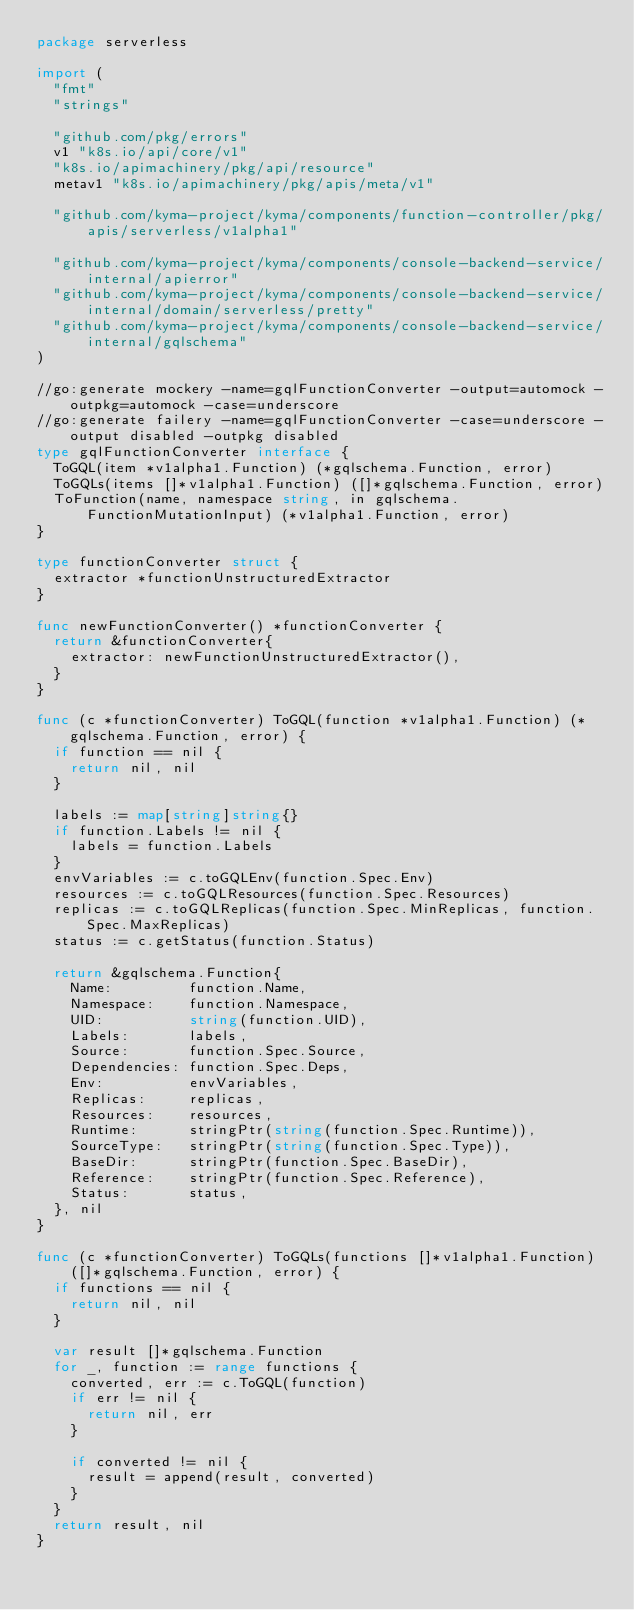Convert code to text. <code><loc_0><loc_0><loc_500><loc_500><_Go_>package serverless

import (
	"fmt"
	"strings"

	"github.com/pkg/errors"
	v1 "k8s.io/api/core/v1"
	"k8s.io/apimachinery/pkg/api/resource"
	metav1 "k8s.io/apimachinery/pkg/apis/meta/v1"

	"github.com/kyma-project/kyma/components/function-controller/pkg/apis/serverless/v1alpha1"

	"github.com/kyma-project/kyma/components/console-backend-service/internal/apierror"
	"github.com/kyma-project/kyma/components/console-backend-service/internal/domain/serverless/pretty"
	"github.com/kyma-project/kyma/components/console-backend-service/internal/gqlschema"
)

//go:generate mockery -name=gqlFunctionConverter -output=automock -outpkg=automock -case=underscore
//go:generate failery -name=gqlFunctionConverter -case=underscore -output disabled -outpkg disabled
type gqlFunctionConverter interface {
	ToGQL(item *v1alpha1.Function) (*gqlschema.Function, error)
	ToGQLs(items []*v1alpha1.Function) ([]*gqlschema.Function, error)
	ToFunction(name, namespace string, in gqlschema.FunctionMutationInput) (*v1alpha1.Function, error)
}

type functionConverter struct {
	extractor *functionUnstructuredExtractor
}

func newFunctionConverter() *functionConverter {
	return &functionConverter{
		extractor: newFunctionUnstructuredExtractor(),
	}
}

func (c *functionConverter) ToGQL(function *v1alpha1.Function) (*gqlschema.Function, error) {
	if function == nil {
		return nil, nil
	}

	labels := map[string]string{}
	if function.Labels != nil {
		labels = function.Labels
	}
	envVariables := c.toGQLEnv(function.Spec.Env)
	resources := c.toGQLResources(function.Spec.Resources)
	replicas := c.toGQLReplicas(function.Spec.MinReplicas, function.Spec.MaxReplicas)
	status := c.getStatus(function.Status)

	return &gqlschema.Function{
		Name:         function.Name,
		Namespace:    function.Namespace,
		UID:          string(function.UID),
		Labels:       labels,
		Source:       function.Spec.Source,
		Dependencies: function.Spec.Deps,
		Env:          envVariables,
		Replicas:     replicas,
		Resources:    resources,
		Runtime:      stringPtr(string(function.Spec.Runtime)),
		SourceType:   stringPtr(string(function.Spec.Type)),
		BaseDir:      stringPtr(function.Spec.BaseDir),
		Reference:    stringPtr(function.Spec.Reference),
		Status:       status,
	}, nil
}

func (c *functionConverter) ToGQLs(functions []*v1alpha1.Function) ([]*gqlschema.Function, error) {
	if functions == nil {
		return nil, nil
	}

	var result []*gqlschema.Function
	for _, function := range functions {
		converted, err := c.ToGQL(function)
		if err != nil {
			return nil, err
		}

		if converted != nil {
			result = append(result, converted)
		}
	}
	return result, nil
}
</code> 